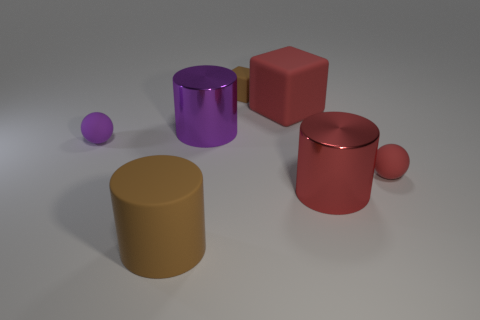What number of other things are the same size as the purple cylinder?
Your response must be concise. 3. What material is the small brown object?
Provide a short and direct response. Rubber. What shape is the red rubber thing that is the same size as the purple rubber sphere?
Offer a very short reply. Sphere. Are the purple thing left of the large brown object and the red ball right of the red block made of the same material?
Provide a short and direct response. Yes. What number of large purple objects are there?
Ensure brevity in your answer.  1. How many big red metallic objects are the same shape as the tiny brown thing?
Ensure brevity in your answer.  0. Do the large brown thing and the large red metal object have the same shape?
Provide a succinct answer. Yes. What size is the brown matte cylinder?
Offer a terse response. Large. How many red cubes have the same size as the purple metallic thing?
Your response must be concise. 1. Do the metallic cylinder that is on the right side of the tiny block and the red thing behind the small red thing have the same size?
Your answer should be very brief. Yes. 